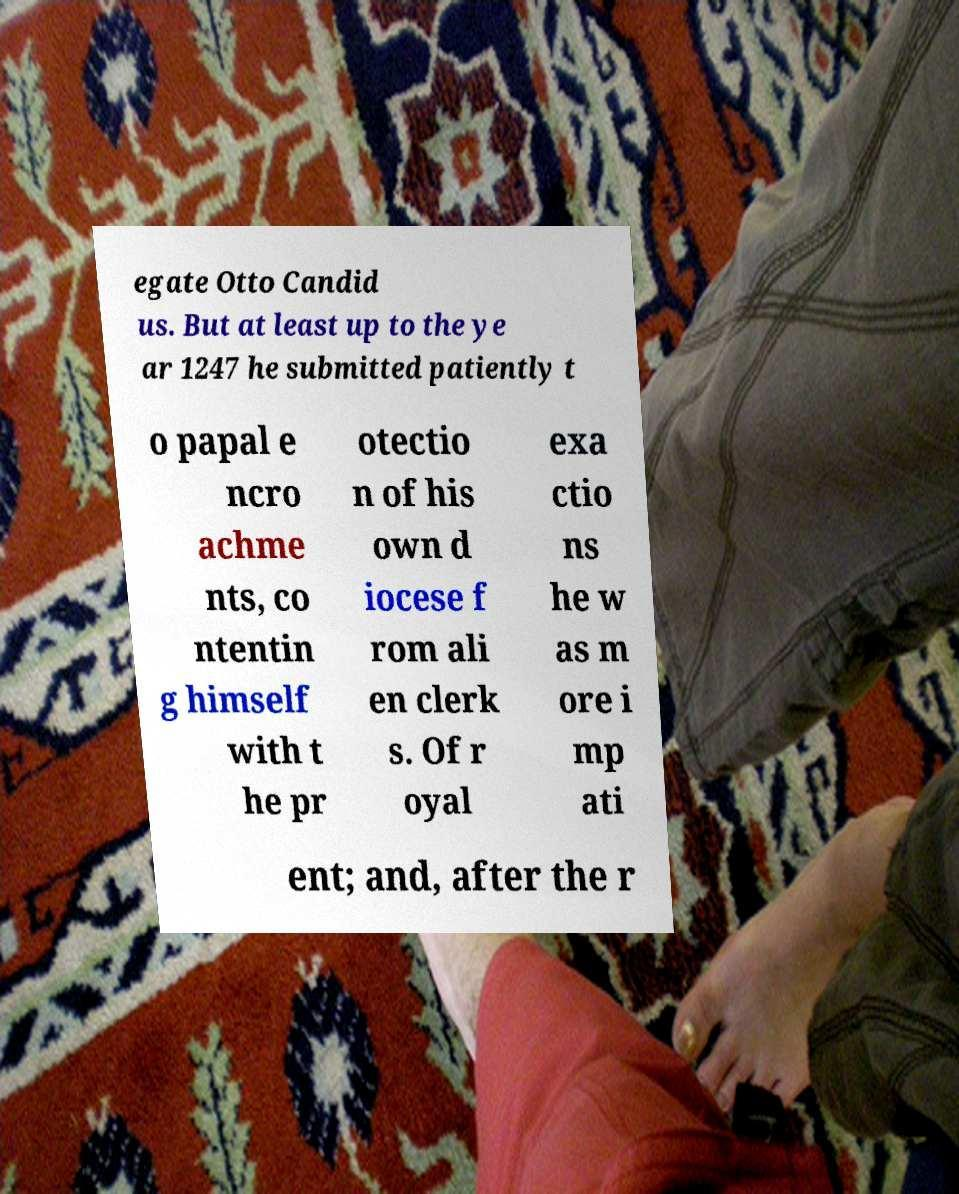I need the written content from this picture converted into text. Can you do that? egate Otto Candid us. But at least up to the ye ar 1247 he submitted patiently t o papal e ncro achme nts, co ntentin g himself with t he pr otectio n of his own d iocese f rom ali en clerk s. Of r oyal exa ctio ns he w as m ore i mp ati ent; and, after the r 